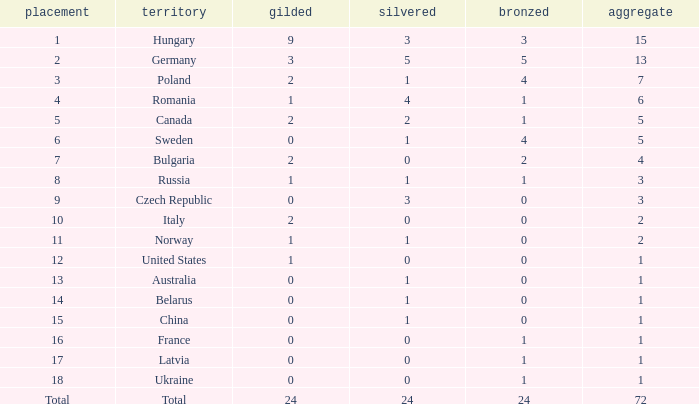How many golds have 3 as the rank, with a total greater than 7? 0.0. 